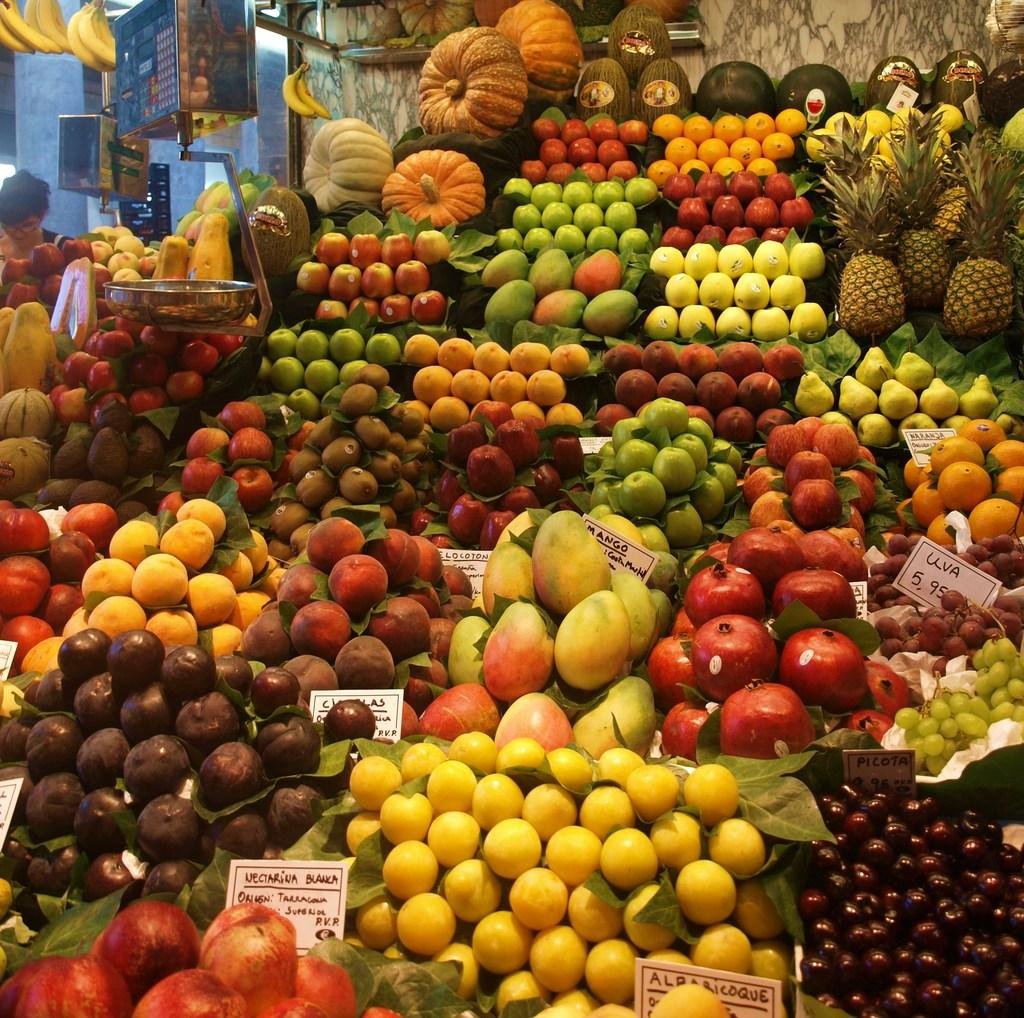What type of establishment does the image resemble? The image resembles a fruit shop. Which specific fruits can be seen in the image? There are pomegranates, mangoes, oranges, apples, litchis, and pineapples in the image. Are there any vegetables present in the image? Yes, there are pumpkins in the image. What type of leaf is used to wrap the coal in the image? There is no leaf or coal present in the image; it consists of fruits and vegetables. 